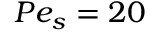Convert formula to latex. <formula><loc_0><loc_0><loc_500><loc_500>P e _ { s } = 2 0</formula> 